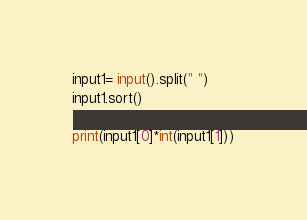Convert code to text. <code><loc_0><loc_0><loc_500><loc_500><_Python_>input1= input().split(" ")
input1.sort()

print(input1[0]*int(input1[1]))</code> 